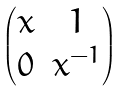<formula> <loc_0><loc_0><loc_500><loc_500>\begin{pmatrix} x & 1 \\ 0 & x ^ { - 1 } \end{pmatrix}</formula> 